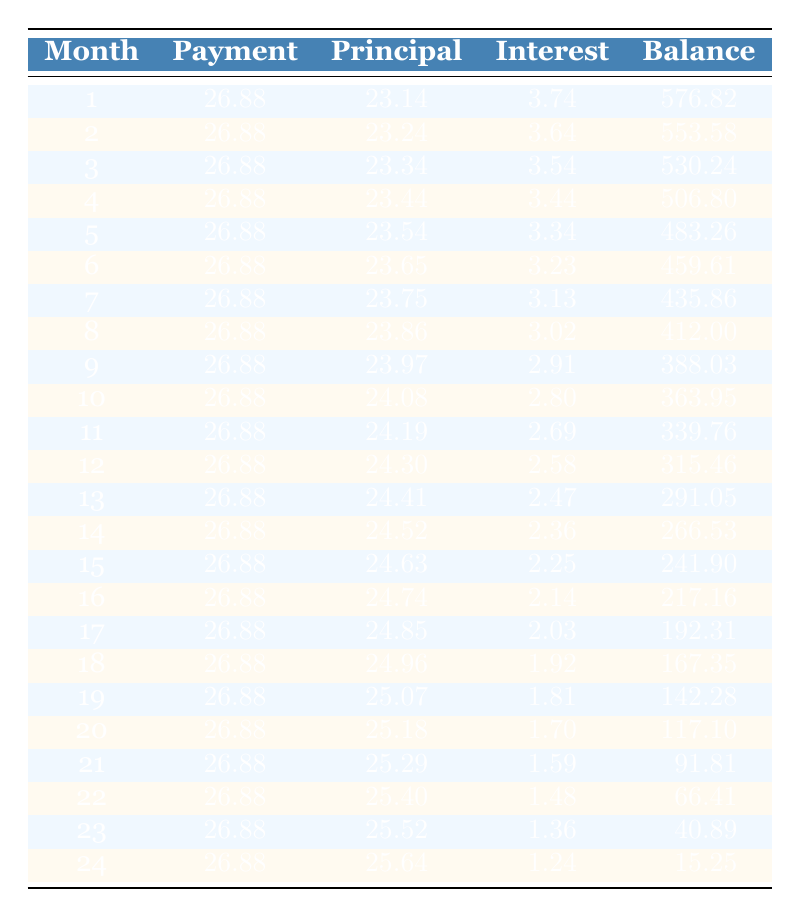What is the monthly payment for the espresso machine? The monthly payment is listed as 26.88 in the table.
Answer: 26.88 How much total interest will be paid over the loan term? The total interest paid is shown to be 45.24 according to the payment schedule.
Answer: 45.24 In which month is the principal payment highest? To find the month with the highest principal payment, I compare the principal amounts across all months. The highest principal payment is 25.64 in the 24th month.
Answer: 24 What is the total amount paid by the end of the loan? The total payment is given as 645.20. This is the sum of all monthly payments over the loan term of 24 months.
Answer: 645.20 Does the interest payment decrease over time? Yes, examining the interest payments over the months in the table shows that each month the interest amount is less than the previous month.
Answer: Yes What is the remaining balance after the 12th payment? The table shows the remaining balance after the 12th month is 315.46.
Answer: 315.46 How much principal is paid in the 10th month? Looking at the payment schedule for the 10th month, the principal paid is listed as 24.08.
Answer: 24.08 What is the average monthly principal payment over the loan term? To find the average, sum all principal payments from 1 to 24 (totaling 581.67) and then divide by the number of months (24), resulting in an average principal payment of approximately 24.07.
Answer: 24.07 How much does the remaining balance change from the 1st month to the 24th month? The remaining balance decreases from 576.82 in the 1st month to 15.25 in the 24th month. The change is 576.82 - 15.25 = 561.57.
Answer: 561.57 